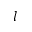<formula> <loc_0><loc_0><loc_500><loc_500>l</formula> 